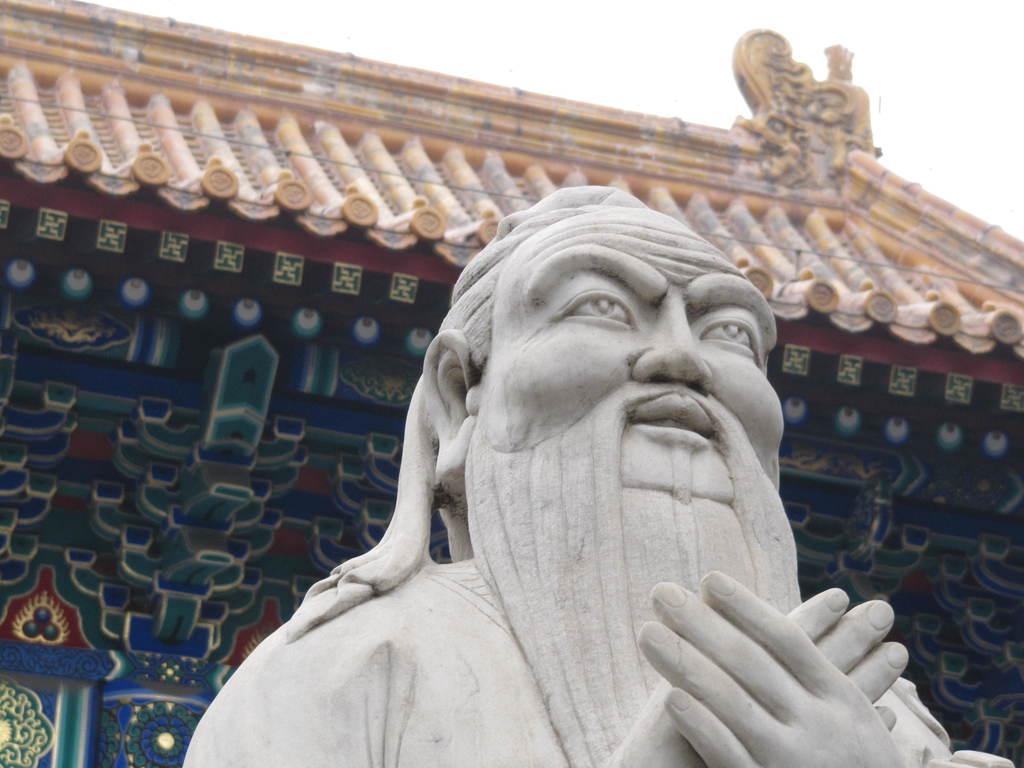How would you summarize this image in a sentence or two? In this picture we can see a statue and an architecture. Behind the architecture there is the sky. 